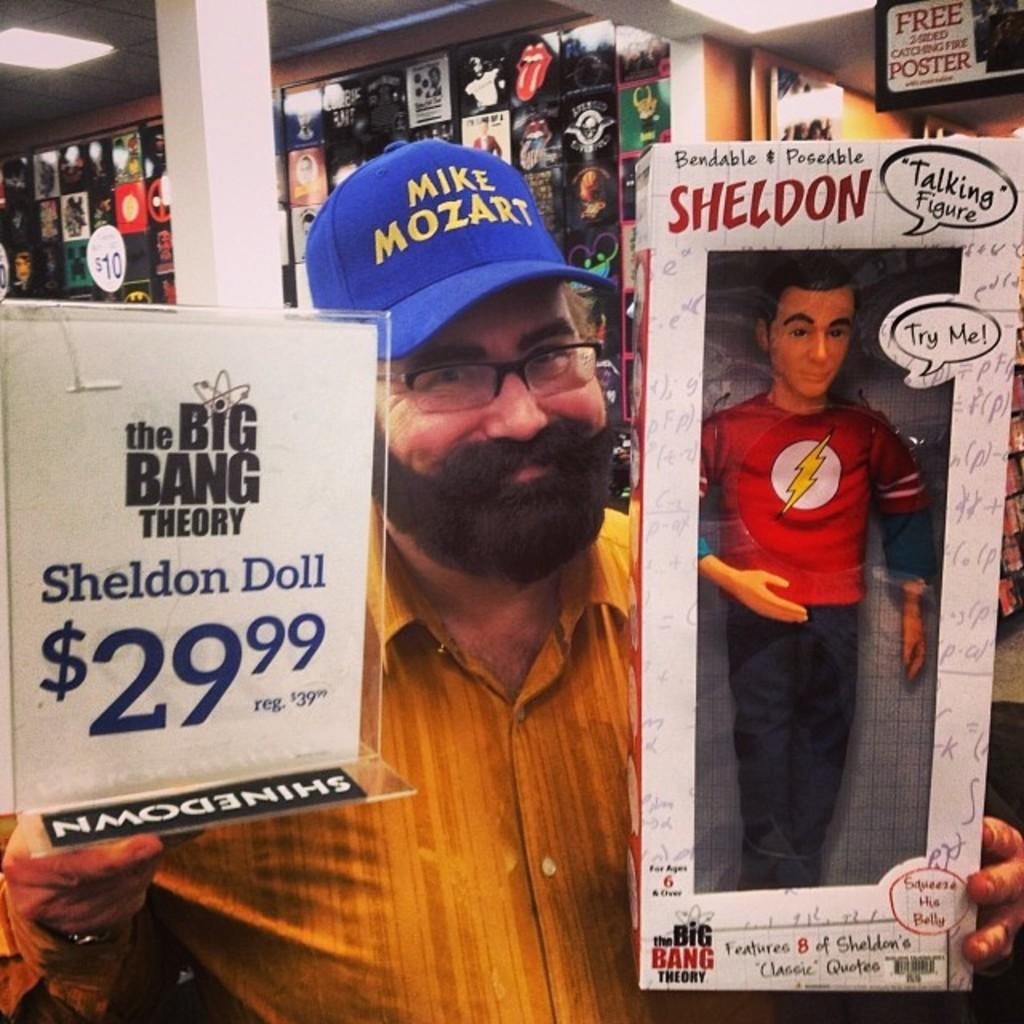What is the man in the image doing? The man is smiling in the image. What is the man wearing on his head? The man is wearing a blue cap. What type of eyewear is the man wearing? The man is wearing spectacles. What objects is the man holding in the image? The man is holding a board and a box. What is inside the box the man is holding? There is a doll in the box. What can be seen in the background of the image? There are posters, pillars, and boards in the background of the image. What is visible at the top of the image? There are lights visible at the top of the image. What type of vest is the dog wearing in the image? There is no dog present in the image, and therefore no vest can be observed. 